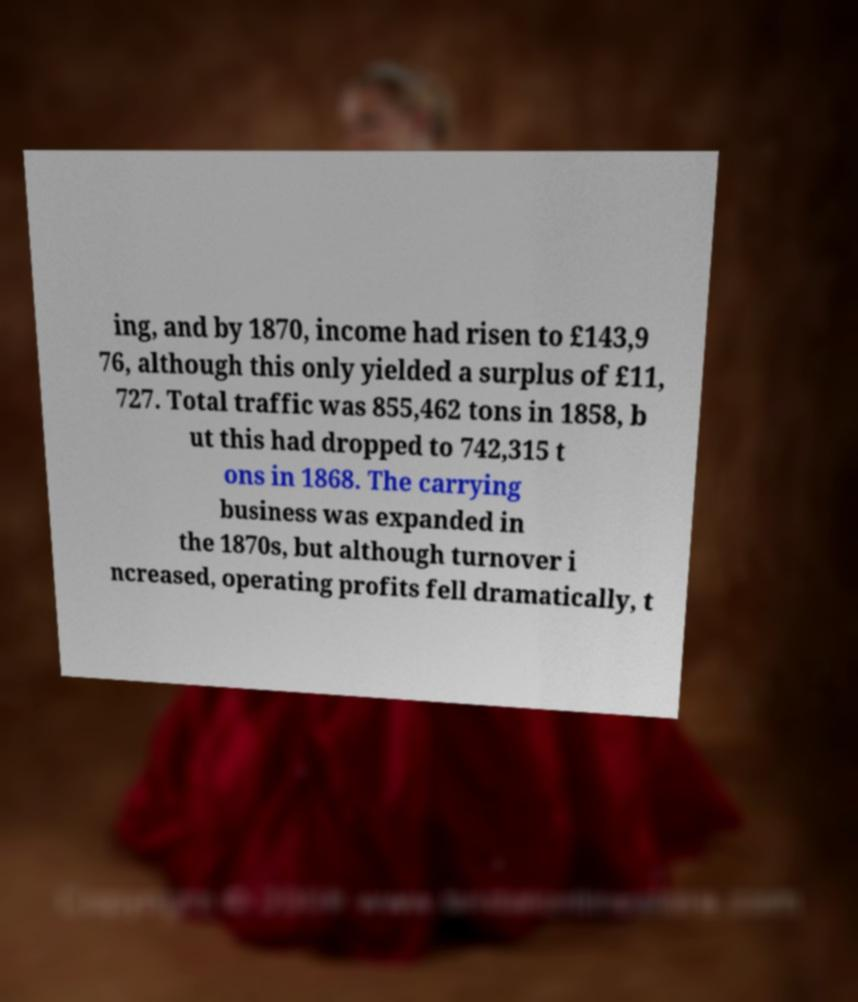There's text embedded in this image that I need extracted. Can you transcribe it verbatim? ing, and by 1870, income had risen to £143,9 76, although this only yielded a surplus of £11, 727. Total traffic was 855,462 tons in 1858, b ut this had dropped to 742,315 t ons in 1868. The carrying business was expanded in the 1870s, but although turnover i ncreased, operating profits fell dramatically, t 